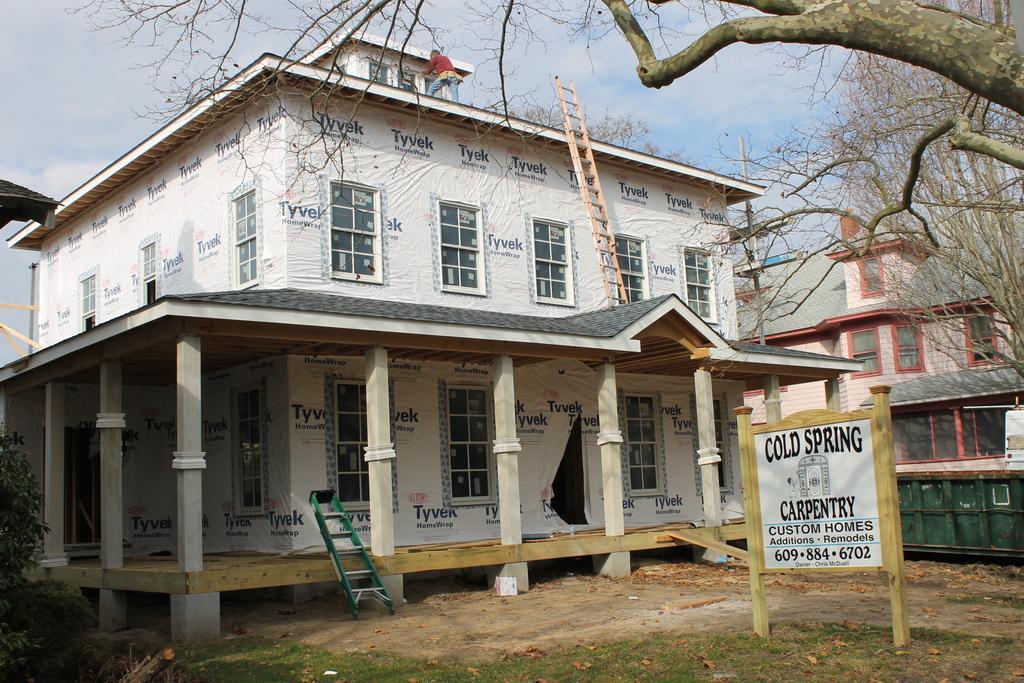Could you give a brief overview of what you see in this image? In the image we can see there is a building and the ground is covered with grass and dry leaves. There is a person standing on the top of the building and behind there is another building. 